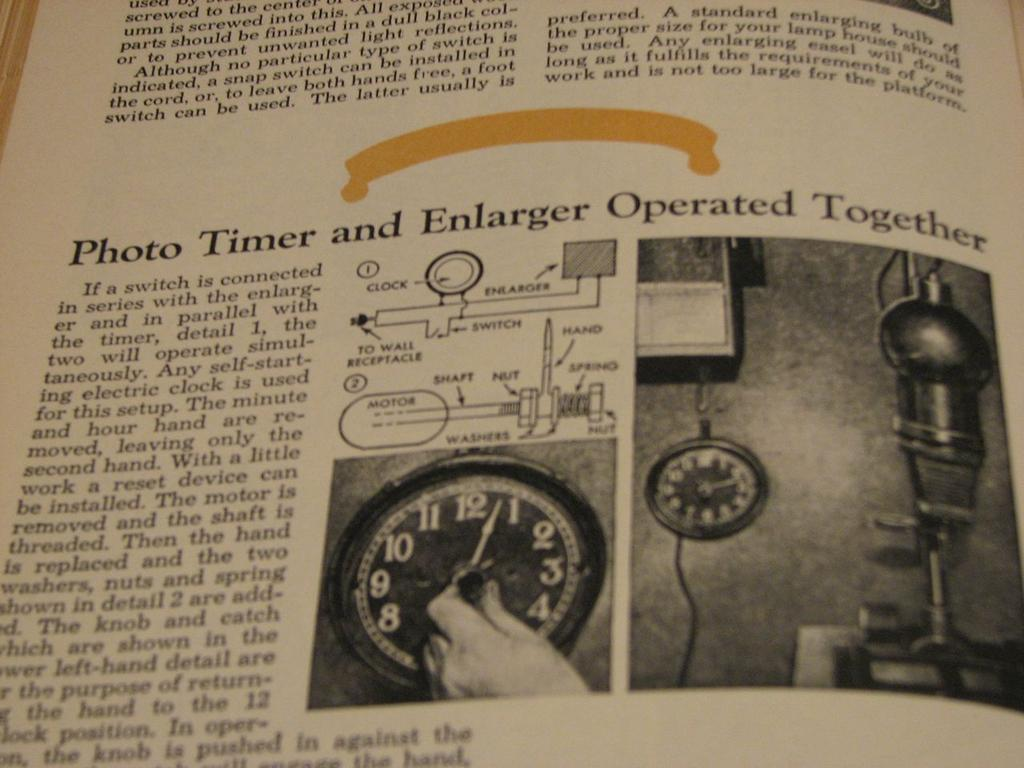What type of object is the image taken from? The image is of a page inside a book. What is one specific item shown on the page? There is a clock in the image. Are there any other objects or tools depicted on the page? Yes, there is other equipment in the image. Is there any text accompanying the image on the page? There is an explanation written beside the picture. How many cars are parked in front of the flock of sheep in the image? There are no cars or sheep present in the image; it is a page from a book with a clock and other equipment. 